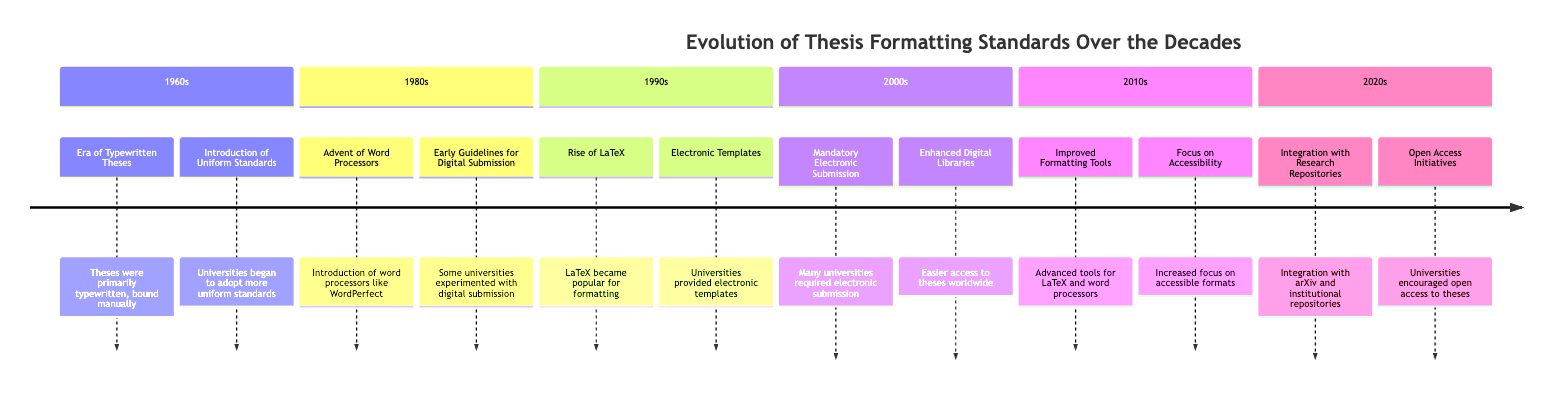What decade saw the introduction of Uniform Standards? According to the timeline, the introduction of Uniform Standards occurred in the 1960s.
Answer: 1960s How many elements are listed for the 1980s? The timeline indicates that there are 2 elements listed for the 1980s: Advent of Word Processors and Early Guidelines for Digital Submission.
Answer: 2 What major technological advancement impacted thesis formatting in the 1990s? The timeline highlights the Rise of LaTeX as a key technological advancement that impacted thesis formatting in the 1990s.
Answer: Rise of LaTeX What decade introduced Mandatory Electronic Submission? The timeline specifies that Mandatory Electronic Submission was introduced in the 2000s.
Answer: 2000s Which decade emphasized a focus on accessibility? The timeline notes that the emphasis on accessibility took place in the 2010s.
Answer: 2010s What are the two significant developments mentioned for the 2020s? The timeline outlines two significant developments for the 2020s: Integration with Research Repositories and Open Access Initiatives.
Answer: Integration with Research Repositories, Open Access Initiatives How has the storage requirement for theses changed since the 2000s? The timeline states that since the 2000s, many universities have made electronic submission mandatory, which significantly reduced physical storage needs for theses.
Answer: Reduced physical storage needs What is common between the 1980s and 1990s elements regarding technology? Both the 1980s and 1990s elements mention technology advancements; the 1980s mention word processors while the 1990s refer to LaTeX.
Answer: Word Processors and LaTeX In which decade did universities start providing electronic templates? The timeline indicates that universities started providing electronic templates in the 1990s.
Answer: 1990s 